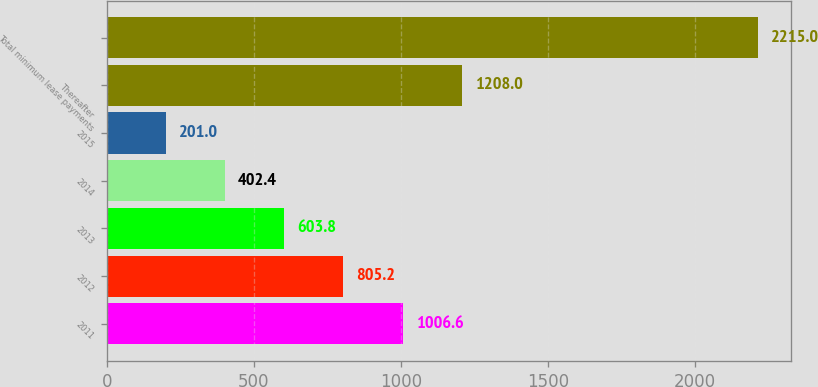Convert chart. <chart><loc_0><loc_0><loc_500><loc_500><bar_chart><fcel>2011<fcel>2012<fcel>2013<fcel>2014<fcel>2015<fcel>Thereafter<fcel>Total minimum lease payments<nl><fcel>1006.6<fcel>805.2<fcel>603.8<fcel>402.4<fcel>201<fcel>1208<fcel>2215<nl></chart> 